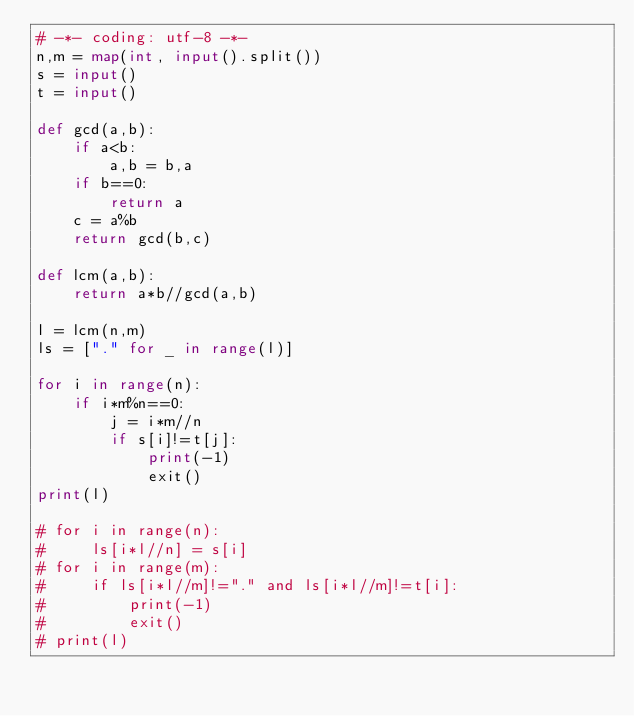<code> <loc_0><loc_0><loc_500><loc_500><_Python_># -*- coding: utf-8 -*-
n,m = map(int, input().split())
s = input()
t = input()

def gcd(a,b):
    if a<b:
        a,b = b,a
    if b==0:
        return a
    c = a%b
    return gcd(b,c)

def lcm(a,b):
    return a*b//gcd(a,b)

l = lcm(n,m)
ls = ["." for _ in range(l)]

for i in range(n):
    if i*m%n==0:
        j = i*m//n
        if s[i]!=t[j]:
            print(-1)
            exit()
print(l)

# for i in range(n):
#     ls[i*l//n] = s[i]
# for i in range(m):
#     if ls[i*l//m]!="." and ls[i*l//m]!=t[i]:
#         print(-1)
#         exit()
# print(l)
</code> 